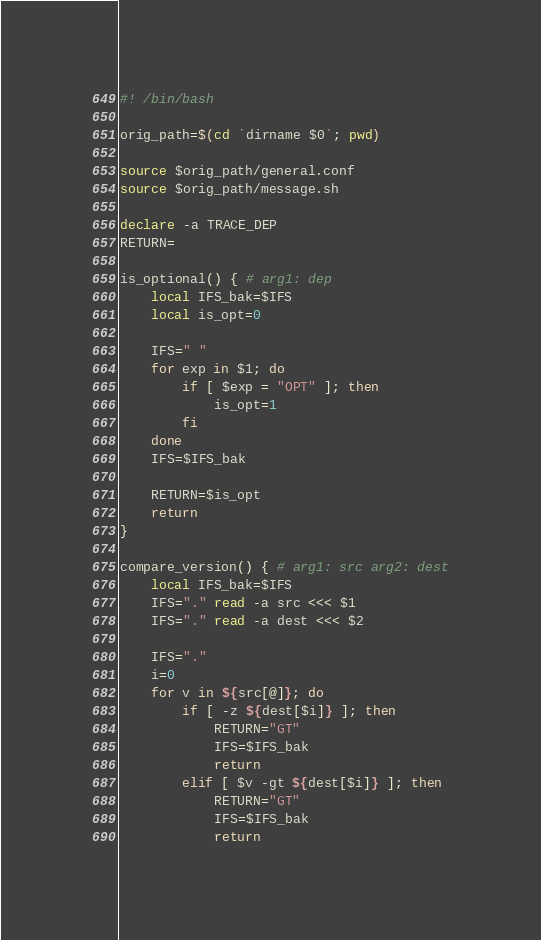Convert code to text. <code><loc_0><loc_0><loc_500><loc_500><_Bash_>#! /bin/bash

orig_path=$(cd `dirname $0`; pwd)

source $orig_path/general.conf
source $orig_path/message.sh

declare -a TRACE_DEP
RETURN=

is_optional() { # arg1: dep
	local IFS_bak=$IFS
	local is_opt=0

	IFS=" "
	for exp in $1; do
		if [ $exp = "OPT" ]; then
			is_opt=1
		fi
	done
	IFS=$IFS_bak

	RETURN=$is_opt
	return
}

compare_version() { # arg1: src arg2: dest
	local IFS_bak=$IFS
	IFS="." read -a src <<< $1
	IFS="." read -a dest <<< $2

	IFS="."
	i=0
	for v in ${src[@]}; do
		if [ -z ${dest[$i]} ]; then
			RETURN="GT"
			IFS=$IFS_bak
			return
		elif [ $v -gt ${dest[$i]} ]; then
			RETURN="GT"
			IFS=$IFS_bak
			return</code> 